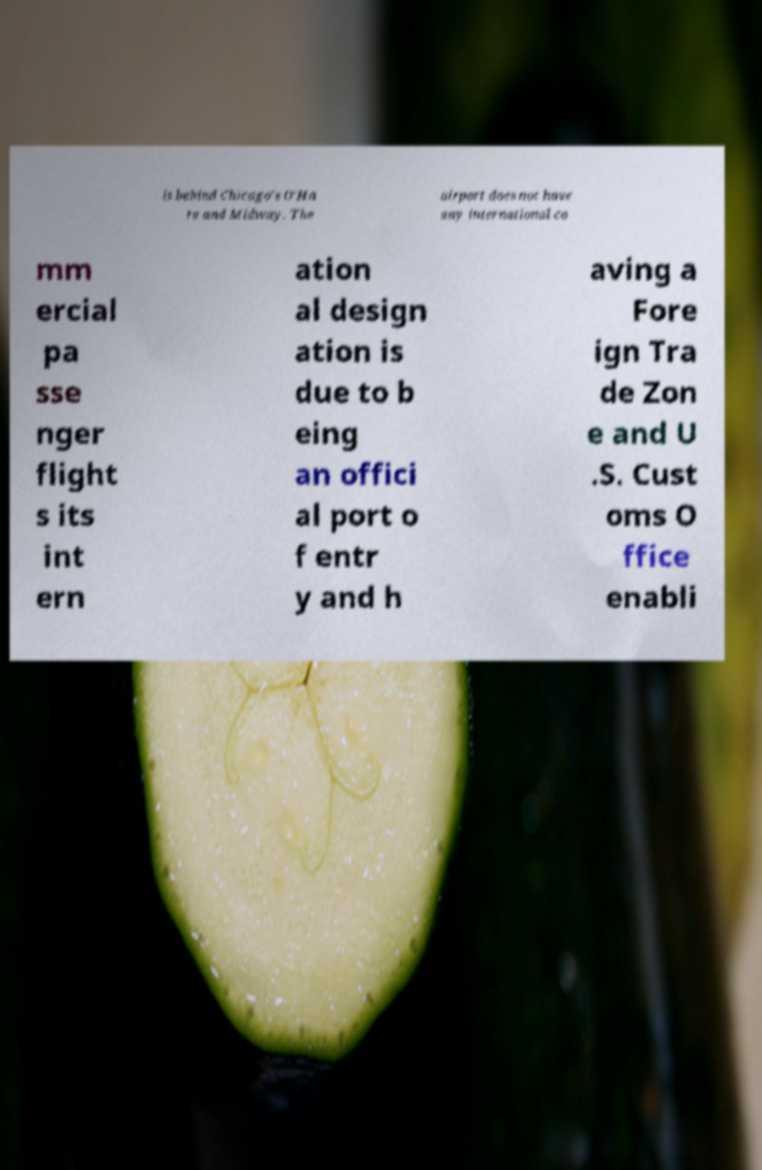What messages or text are displayed in this image? I need them in a readable, typed format. is behind Chicago's O'Ha re and Midway. The airport does not have any international co mm ercial pa sse nger flight s its int ern ation al design ation is due to b eing an offici al port o f entr y and h aving a Fore ign Tra de Zon e and U .S. Cust oms O ffice enabli 